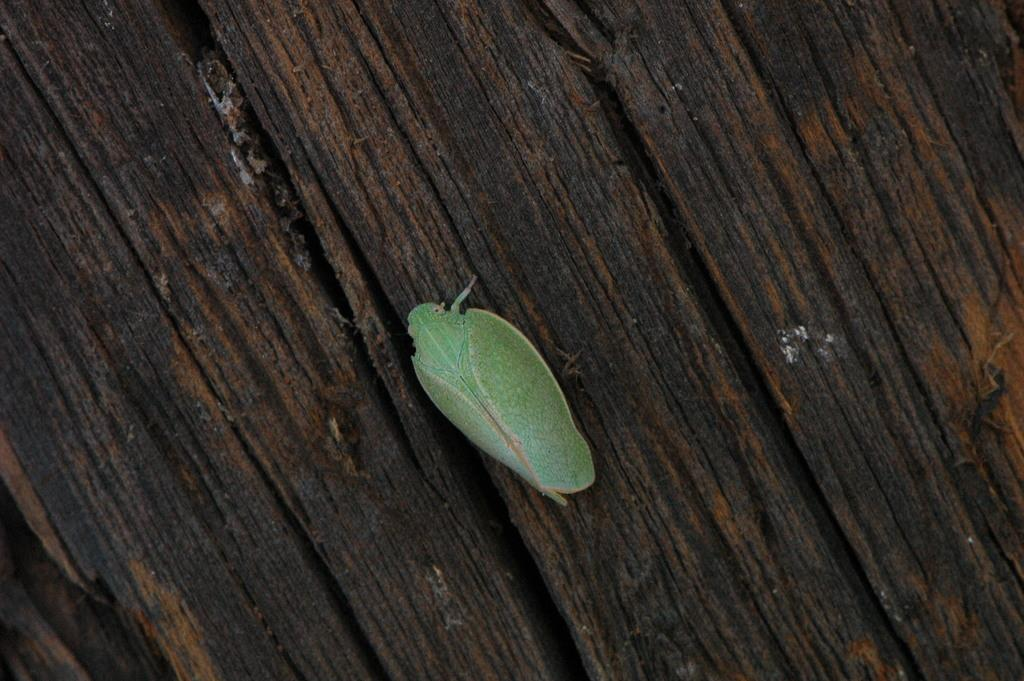What type of creature is in the image? There is an insect in the image. What color is the insect? The insect is green in color. What surface is the insect on? The insect is on a wooden surface. What language is the insect speaking in the image? Insects do not speak human languages, so there is no language spoken by the insect in the image. 